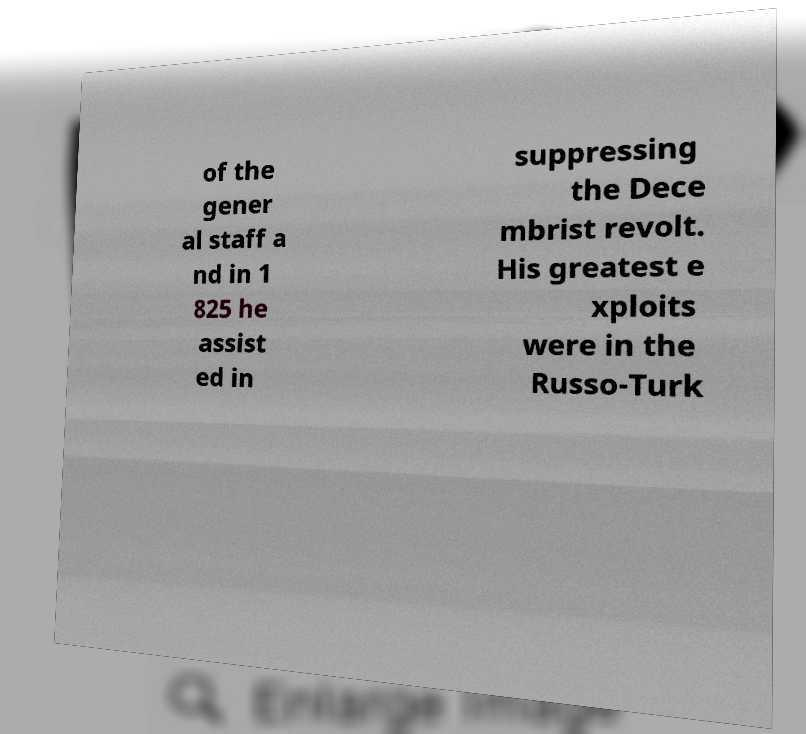What messages or text are displayed in this image? I need them in a readable, typed format. of the gener al staff a nd in 1 825 he assist ed in suppressing the Dece mbrist revolt. His greatest e xploits were in the Russo-Turk 